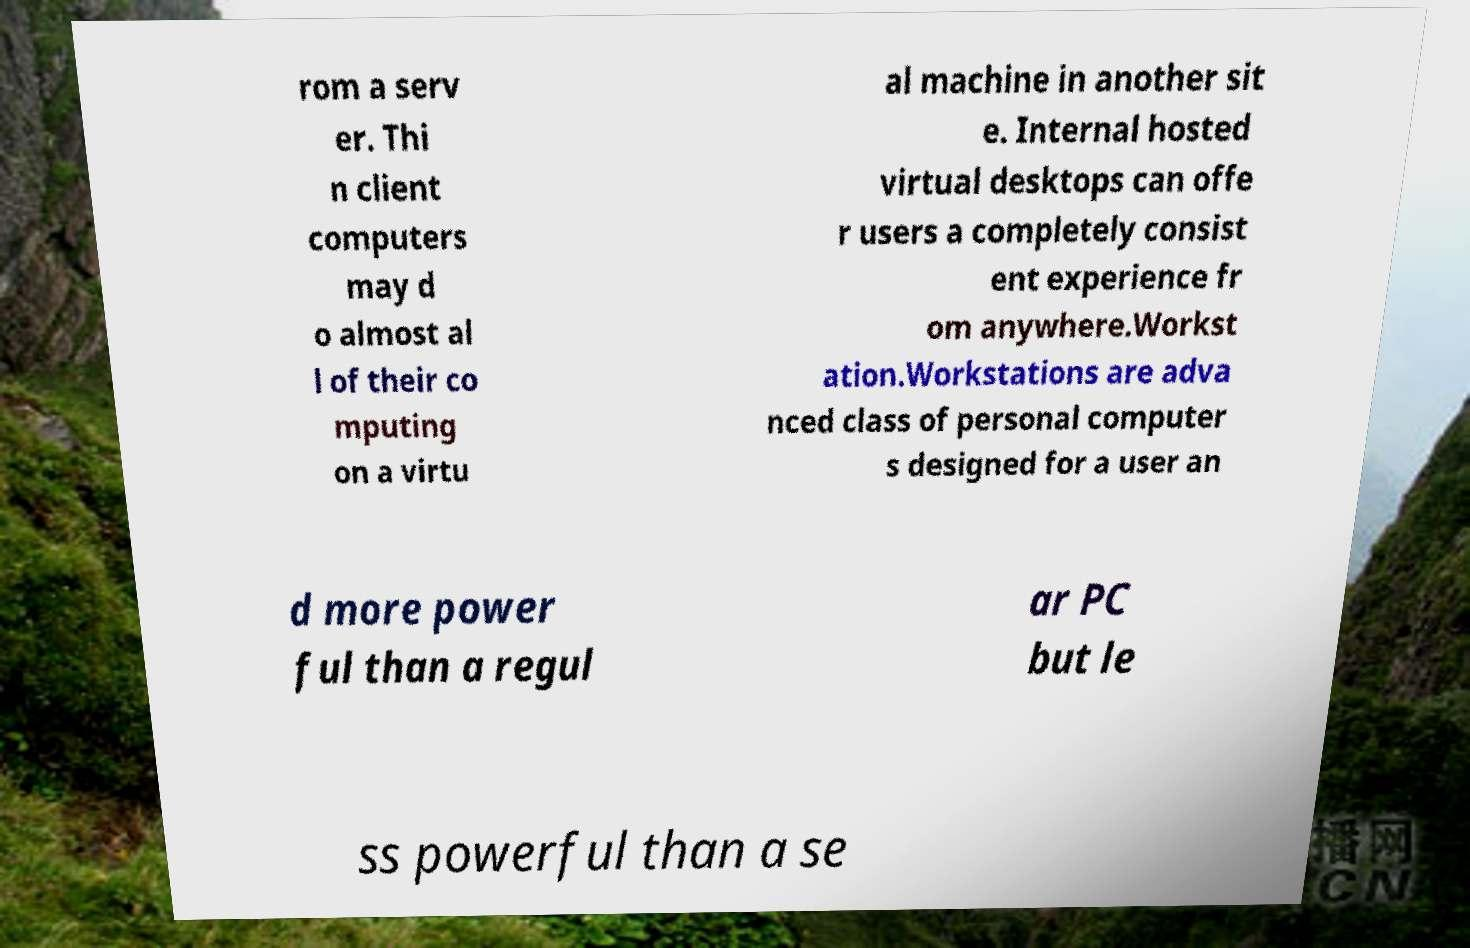For documentation purposes, I need the text within this image transcribed. Could you provide that? rom a serv er. Thi n client computers may d o almost al l of their co mputing on a virtu al machine in another sit e. Internal hosted virtual desktops can offe r users a completely consist ent experience fr om anywhere.Workst ation.Workstations are adva nced class of personal computer s designed for a user an d more power ful than a regul ar PC but le ss powerful than a se 